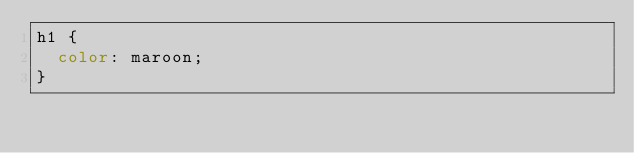Convert code to text. <code><loc_0><loc_0><loc_500><loc_500><_CSS_>h1 {
  color: maroon;
}</code> 